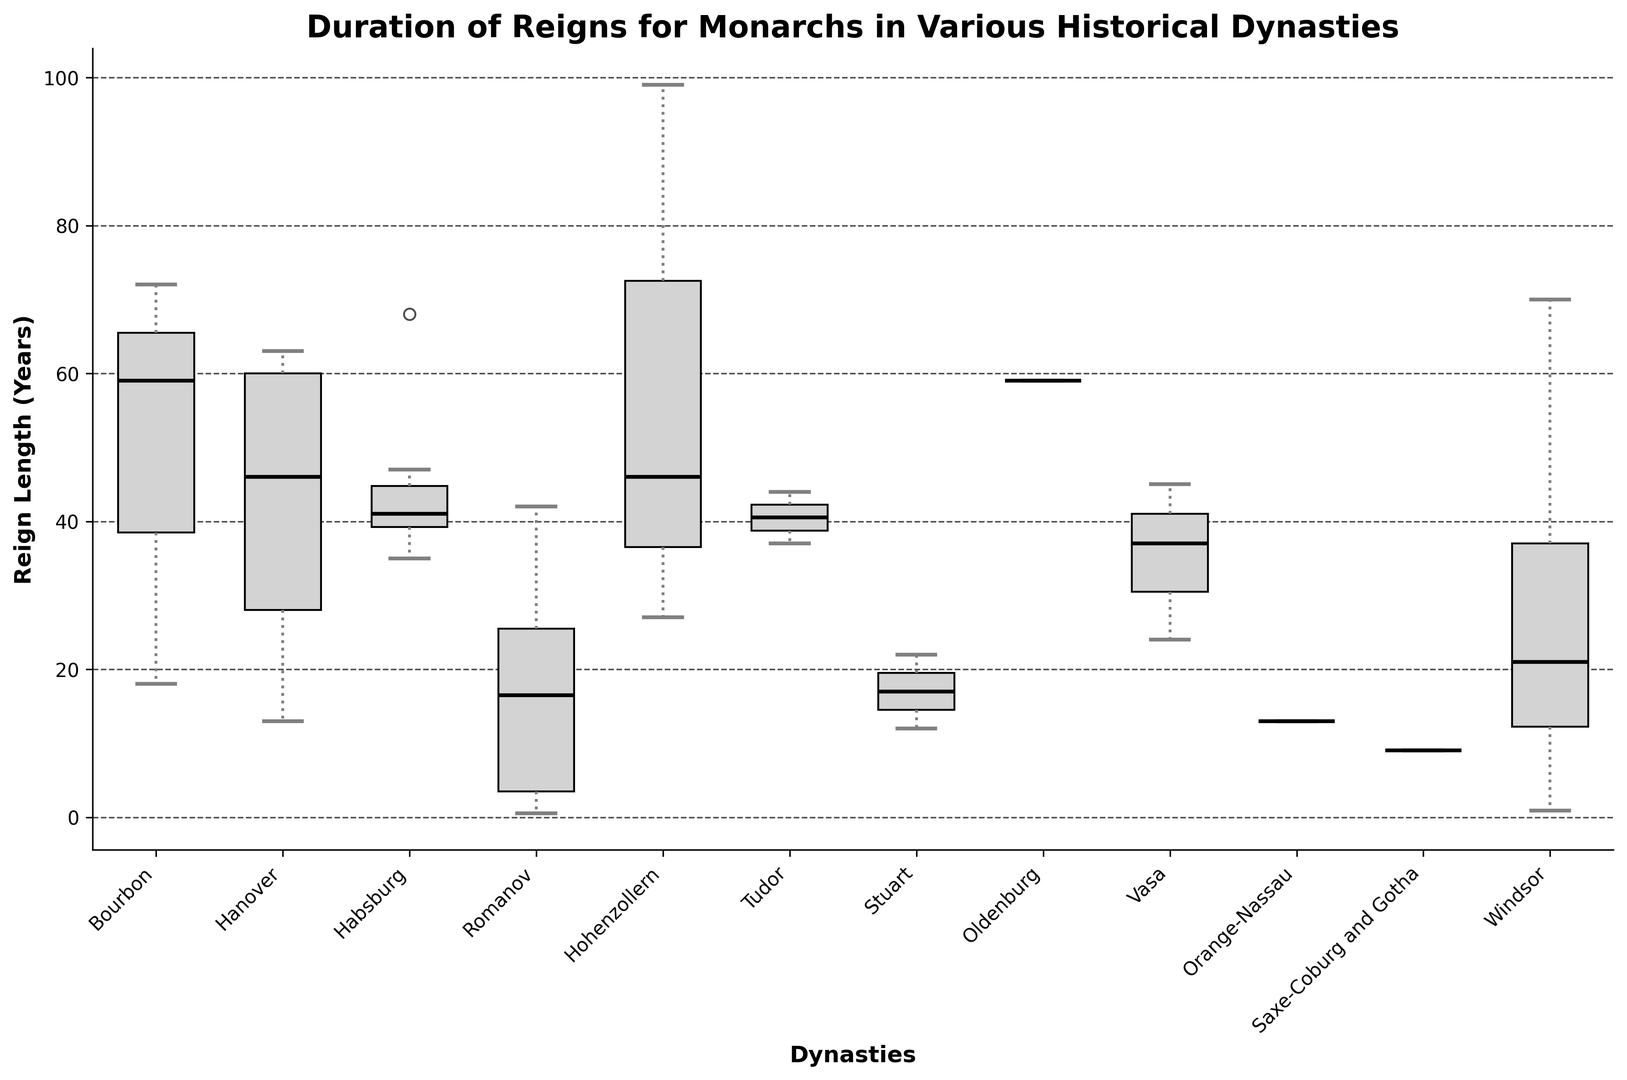Which dynasty has the longest median reign? To determine which dynasty has the longest median reign, look for the median line inside each box representing the reign lengths of each dynasty. The median reign is the middle value of the dataset when it is ordered.
Answer: Habsburg Which dynasty has the shortest whisker length? Whisker length in a box plot represents the spread of most of the data (excluding outliers). Find the dynasty with the smallest distance between the top and bottom whiskers.
Answer: Romanov Between the Bourbons and the Tudors, which dynasty shows greater variability in reign lengths? Variability is indicated by the range of the box and the whiskers. Larger boxes and longer whiskers indicate greater variability. Compare the box sizes and whisker lengths of Bourbon and Tudor.
Answer: Bourbons What is the approximate interquartile range (IQR) of the reign lengths for the Hanover dynasty? The IQR is the difference between the third quartile (Q3) and the first quartile (Q1). Find the lengths of these quartiles in the Hanover box plot, then subtract Q1 from Q3.
Answer: Approximately 26 years Which dynasty has the highest median reign longer than 40 years and the lowest whisker below 10 years? Identify the dynasty that satisfies both conditions: a high median line (above 40 years) and a whisker that reaches below 10 years.
Answer: Habsburg Comparatively, which dynasty has more outliers, the Romanov or the Hanover? Outliers are represented by individual dots above or below the whiskers. Count and compare the number of outliers in the Romanov and Hanover box plots.
Answer: Romanov Which dynasty has reigns that occasionally last below 5 years but also above 65 years? Look for a dynasty whose box plot whiskers and possibly outliers extend below 5 years and above 65 years.
Answer: Romanov What is the median reign length for the dynasty with the longest overall reign? First, identify the dynasty with the longest overall reign by checking the maximum end of the whiskers. Then, find the median reign length within that dynasty’s box plot.
Answer: 40 years (Habsburg) Between the Hohenzollern and Windsor dynasties, which has a more consistent reign length (less variability)? Compare the overall spread of the data (box size and whisker length) between Hohenzollern and Windsor. The dynasty with a smaller box and shorter whiskers exhibits more consistency.
Answer: Windsor 